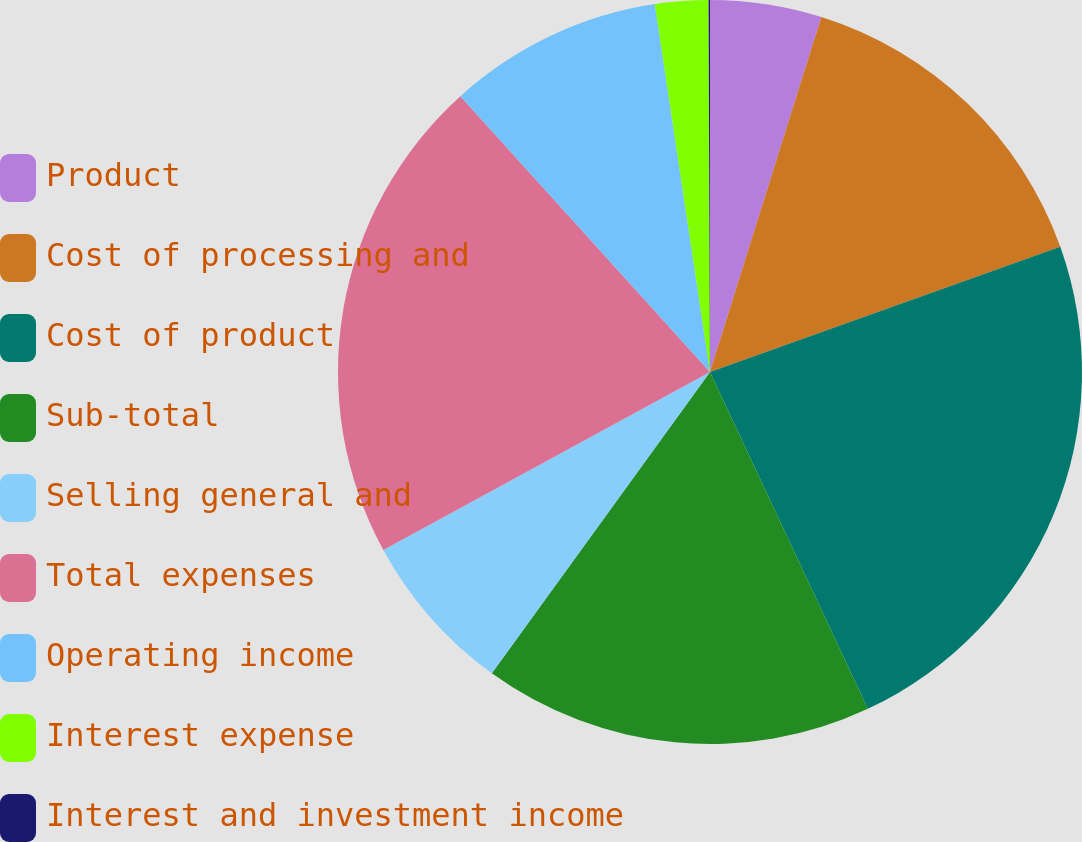<chart> <loc_0><loc_0><loc_500><loc_500><pie_chart><fcel>Product<fcel>Cost of processing and<fcel>Cost of product<fcel>Sub-total<fcel>Selling general and<fcel>Total expenses<fcel>Operating income<fcel>Interest expense<fcel>Interest and investment income<nl><fcel>4.84%<fcel>14.7%<fcel>23.49%<fcel>16.95%<fcel>7.09%<fcel>21.23%<fcel>9.34%<fcel>2.31%<fcel>0.06%<nl></chart> 